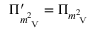Convert formula to latex. <formula><loc_0><loc_0><loc_500><loc_500>\Pi _ { m _ { V } ^ { 2 } } ^ { \prime } = \Pi _ { m _ { V } ^ { 2 } }</formula> 